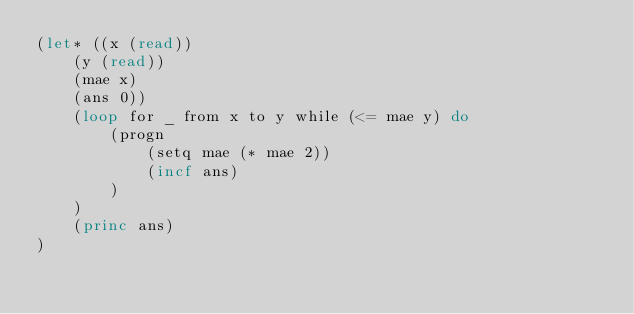Convert code to text. <code><loc_0><loc_0><loc_500><loc_500><_Lisp_>(let* ((x (read))
    (y (read))
    (mae x)
    (ans 0))
    (loop for _ from x to y while (<= mae y) do
        (progn
            (setq mae (* mae 2))
            (incf ans)
        )
    )
    (princ ans)
)</code> 